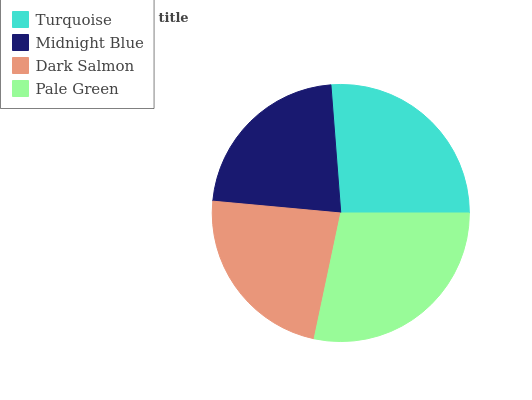Is Midnight Blue the minimum?
Answer yes or no. Yes. Is Pale Green the maximum?
Answer yes or no. Yes. Is Dark Salmon the minimum?
Answer yes or no. No. Is Dark Salmon the maximum?
Answer yes or no. No. Is Dark Salmon greater than Midnight Blue?
Answer yes or no. Yes. Is Midnight Blue less than Dark Salmon?
Answer yes or no. Yes. Is Midnight Blue greater than Dark Salmon?
Answer yes or no. No. Is Dark Salmon less than Midnight Blue?
Answer yes or no. No. Is Turquoise the high median?
Answer yes or no. Yes. Is Dark Salmon the low median?
Answer yes or no. Yes. Is Dark Salmon the high median?
Answer yes or no. No. Is Turquoise the low median?
Answer yes or no. No. 